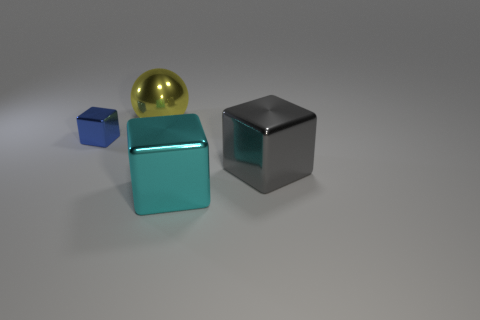There is a thing that is behind the object that is left of the big shiny object behind the gray metallic object; what size is it?
Make the answer very short. Large. There is a large block left of the gray metallic object; how many blue blocks are to the left of it?
Offer a terse response. 1. What is the size of the metallic thing that is on the left side of the cyan thing and in front of the yellow metal object?
Keep it short and to the point. Small. What number of rubber objects are yellow spheres or red balls?
Your response must be concise. 0. What is the material of the large ball?
Make the answer very short. Metal. What material is the cube left of the metallic object that is behind the block that is to the left of the yellow metallic object?
Ensure brevity in your answer.  Metal. What shape is the yellow object that is the same size as the gray metallic thing?
Your answer should be very brief. Sphere. What number of objects are large yellow objects or cubes right of the big cyan metal object?
Ensure brevity in your answer.  2. Is the material of the cube on the left side of the large yellow metallic thing the same as the large object behind the small shiny object?
Your response must be concise. Yes. How many cyan objects are cubes or metal objects?
Your answer should be compact. 1. 